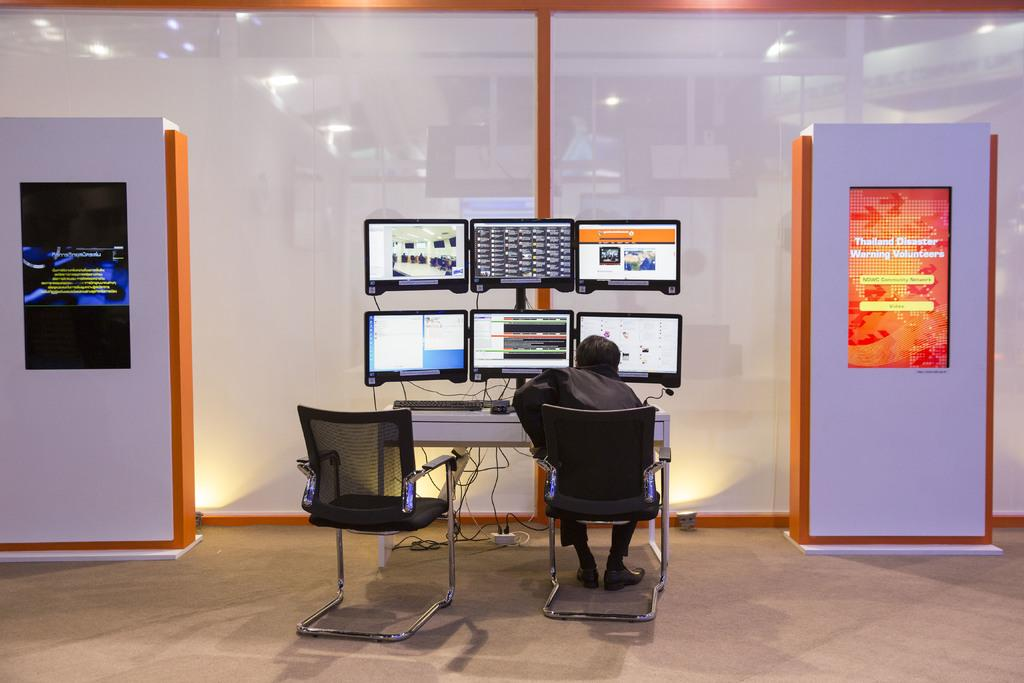What is the person in the image doing? The person is sitting on a chair in the image. What object is the person sitting on? There is a chair in the image. What can be seen in the background of the image? There are 2 digital boards, a glass, 6 screens, and a table in the background of the image. How many tomatoes are on the table in the image? There are no tomatoes present in the image. What discovery was made by the person sitting on the chair in the image? There is no indication of a discovery in the image; the person is simply sitting on a chair. 